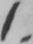Can you tell me what this handwritten text says? 1 . 